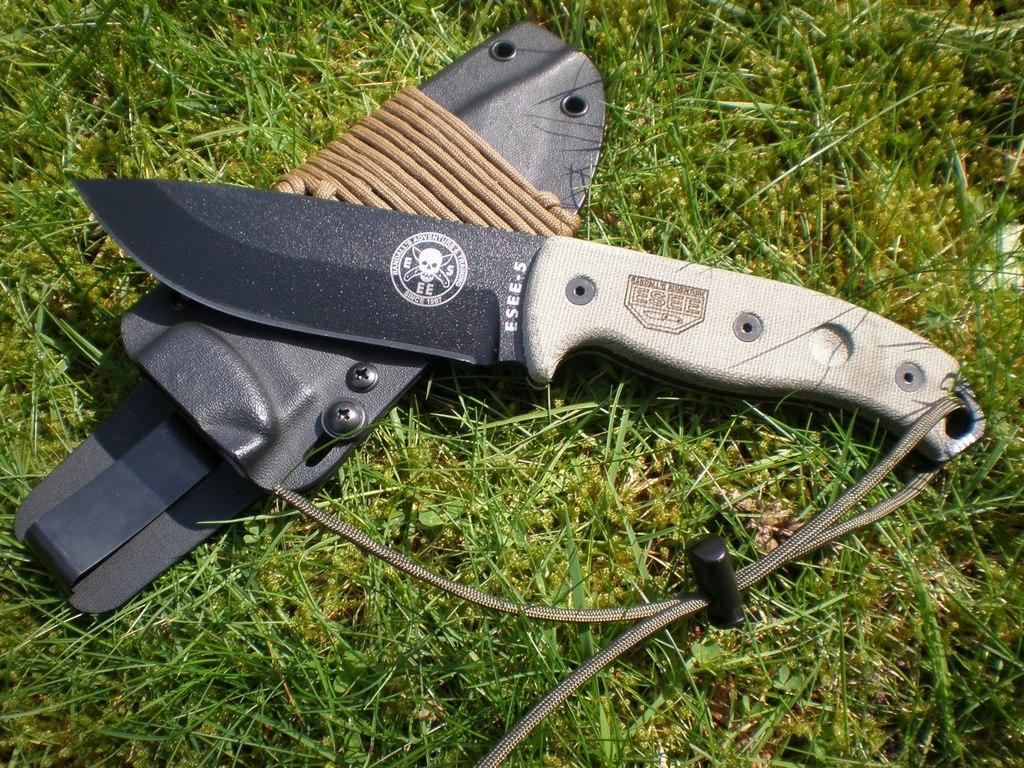What object is present in the image that is typically used for cutting? There is a knife in the image. What other object is present in the image that might be used for carrying or storing the knife? There is a pouch in the image. Where are the knife and pouch located in the image? The knife and its pouch are placed on a grass field. What type of grain is being harvested in the image? There is no indication of any grain or harvesting activity in the image. What flavor of ice cream is being served in the tub in the image? There is no tub or ice cream present in the image. 